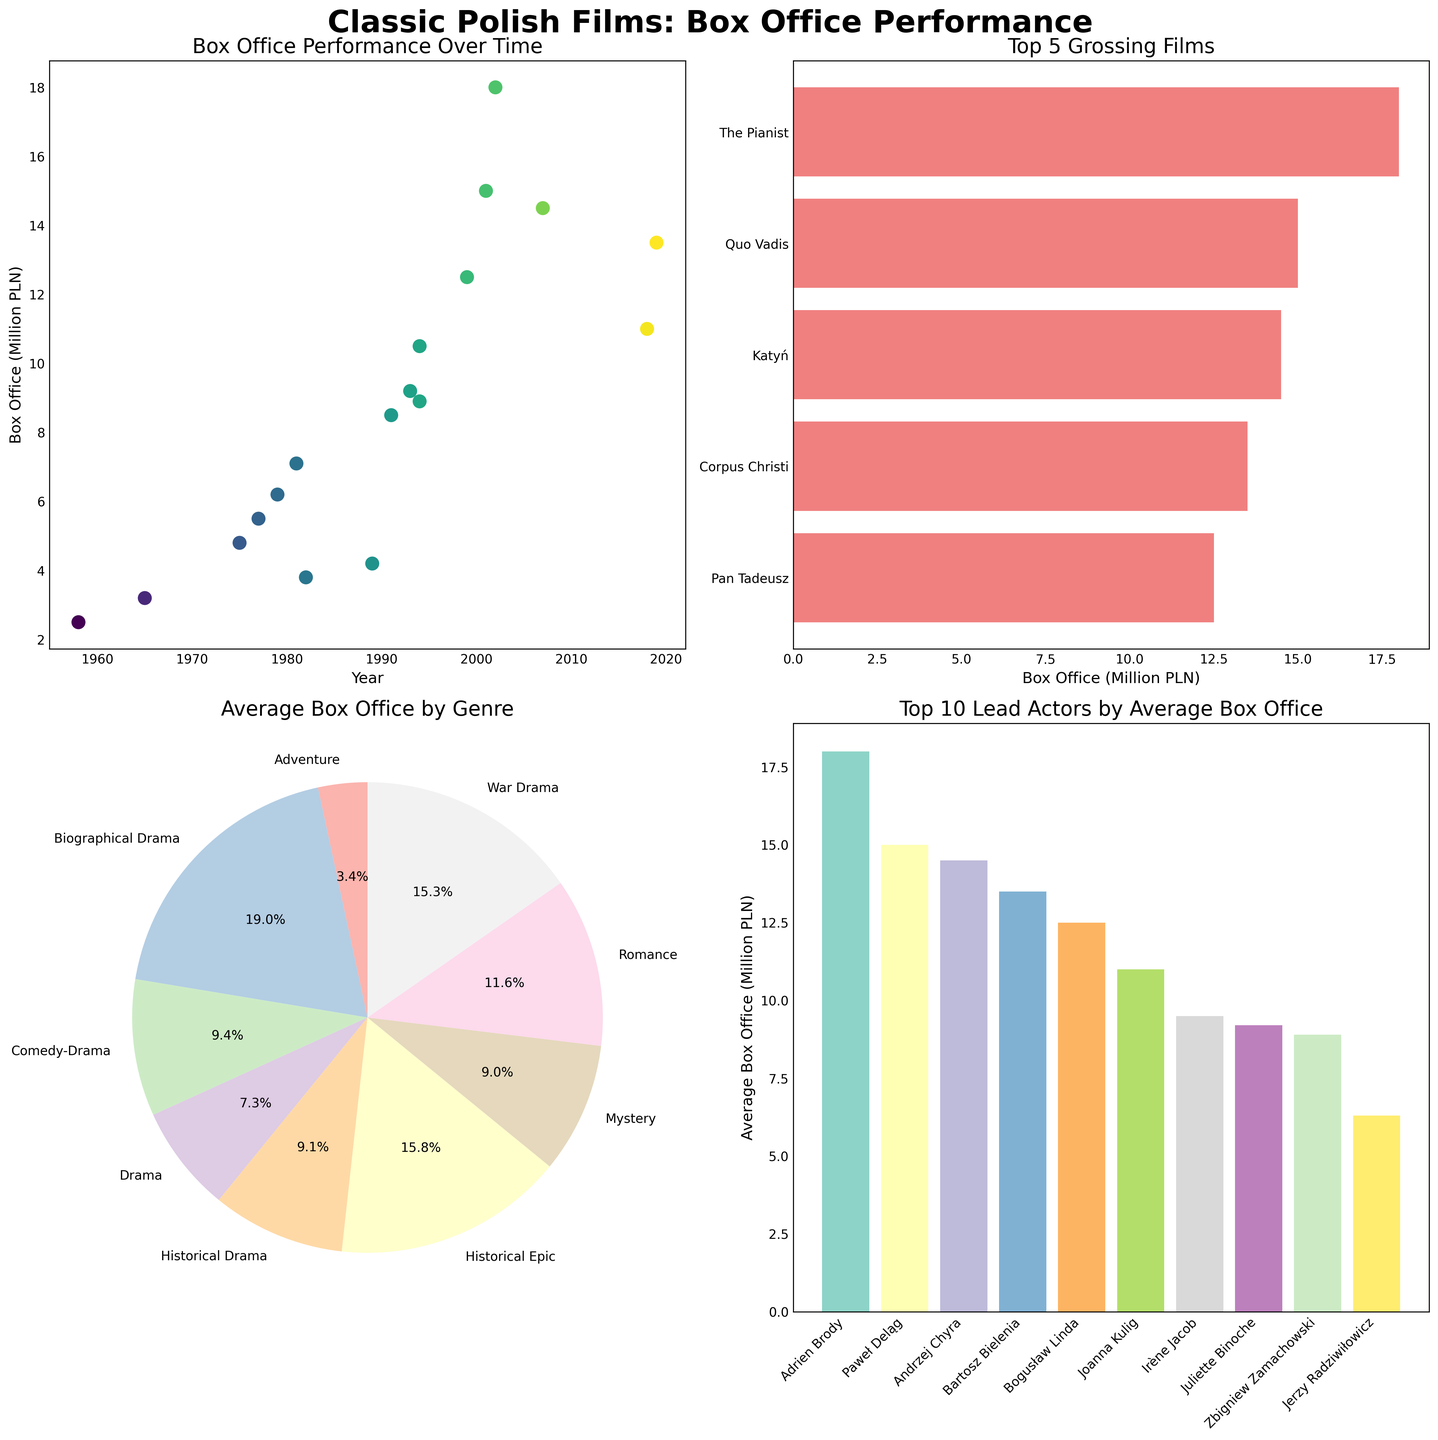What is the range of years covered in the box office performance over time subplot? The x-axis in the subplot "Box Office Performance Over Time" shows years ranging from the earliest year (1958) to the latest year (2019).
Answer: 1958-2019 Which film has the highest box office gross? In the "Top 5 Grossing Films" subplot, the film with the highest box office gross is shown at the top. The highest box office grossing film is "The Pianist" with 18 million PLN.
Answer: The Pianist How does the average box office of "Historical Drama" compare to "Comedy-Drama"? In the "Average Box Office by Genre" subplot, both genres are represented in the pie chart. The exact comparison shows "Historical Drama" has 22.3% and "Comedy-Drama" has 14.1% of the average box office. Historical Drama has a higher average box office when converted from percentages to values.
Answer: Higher What is the combined box office gross of the top 5 grossing films? The "Top 5 Grossing Films" subplot indicates the box office values. Summing them yields: 18 + 15 + 14.5 + 13.5 + 12.5 = 73.5 million PLN.
Answer: 73.5 million PLN Which lead actor has the highest average box office gross? In the "Top 10 Lead Actors by Average Box Office" subplot, the actor with the highest bar indicates the greatest average box office gross. Irène Jacob has the highest average.
Answer: Irène Jacob Which genre has the lowest average box office gross? The smallest segment in the "Average Box Office by Genre" pie chart corresponds to the genre with the lowest average box office gross, which is "Adventure".
Answer: Adventure What is the average box office of the films led by Adrian Brody? In the "Top 10 Lead Actors by Average Box Office" subplot, Adrian Brody's figure is directly represented as a bar value. Adrian Brody led "The Pianist" which grossed 18 million PLN. Since it is one film by Adrian Brody in the dataset, the average is the same as the value.
Answer: 18 million PLN Is there any year in the 1980s shown in the "Box Office Performance Over Time" subplot? If yes, which ones? The scatter plot in "Box Office Performance Over Time" shows points at various years, highlighting both 1981 and 1989 within the 1980s decade.
Answer: Yes, 1981 and 1989 What percentage of the total average box office does the Drama genre represent? In the "Average Box Office by Genre" subplot, the Drama genre represents 34.8% as indicated on the pie chart.
Answer: 34.8% 